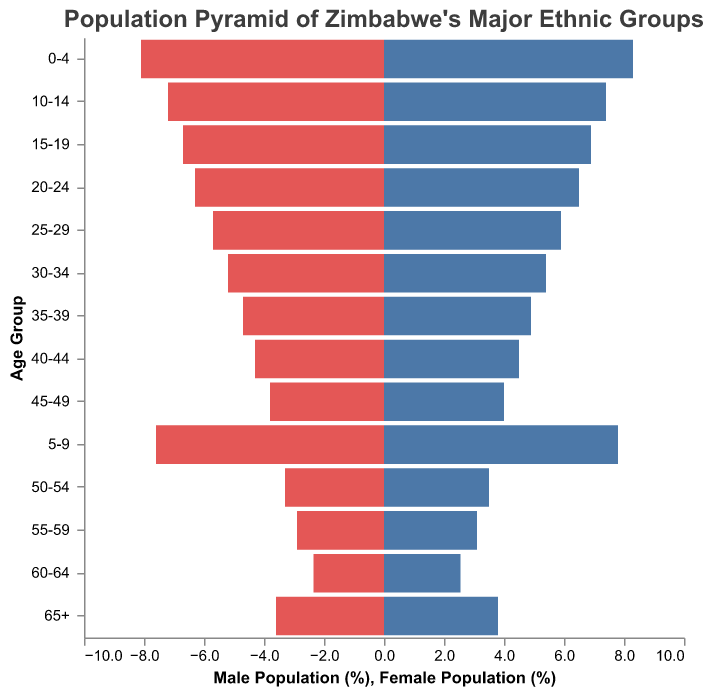What is the title of the figure? The title of the figure is located at the top and it describes the content of the plot.
Answer: Population Pyramid of Zimbabwe's Major Ethnic Groups What does the y-axis represent? The y-axis shows the different age groups, which are intervals in chronological order from youngest to oldest.
Answer: Age Group What color represents the male population? The color used for the bars representing the male population is provided in the figure.
Answer: Blue Which age group has the highest population for the Shona ethnic group? By comparing the percentages for Shona males and females across all age groups, we can see which age group totals the highest population. The age group 0-4 has the highest combined percentage (5.2 + 5.1 = 10.3).
Answer: 0-4 How does the female population of the Ndebele group in the age group 15-19 compare to the male population of the same group? We look at the percentages for Ndebele males and females in the 15-19 age group. The male population is 1.8% while the female population is 1.7%.
Answer: Male population is higher What is the total percentage population of the Kalanga ethnic group for the age group 25-29? Sum the percentages of Kalanga males and females in the age group 25-29. This includes 0.4% (male) + 0.4% (female) = 0.8%.
Answer: 0.8% Which age group has the lowest percentage of the Tonga female population? By comparing the percentages of Tonga females across all age groups, we see that the lowest percentage is in the age group 60-64 with a value of 0.05%.
Answer: 60-64 What can be inferred about the population structure of older age groups (65+) for both males and females across all ethnic groups? By analyzing the percentages in the 65+ age group, we see that there is a consistent decrease in population percentages compared to younger age groups indicating lower representation in older age groups for every ethnic group.
Answer: Population decreases In which age group does the combined population of Shona males and females equal the combined population of Ndebele males and females? We compare the combined percentages of Shona and Ndebele populations across age groups. For age group 50-54, Shona males plus females (2.3 + 2.2 = 4.5) equals Ndebele males plus females (0.9 + 0.8 = 1.7).
Answer: None 